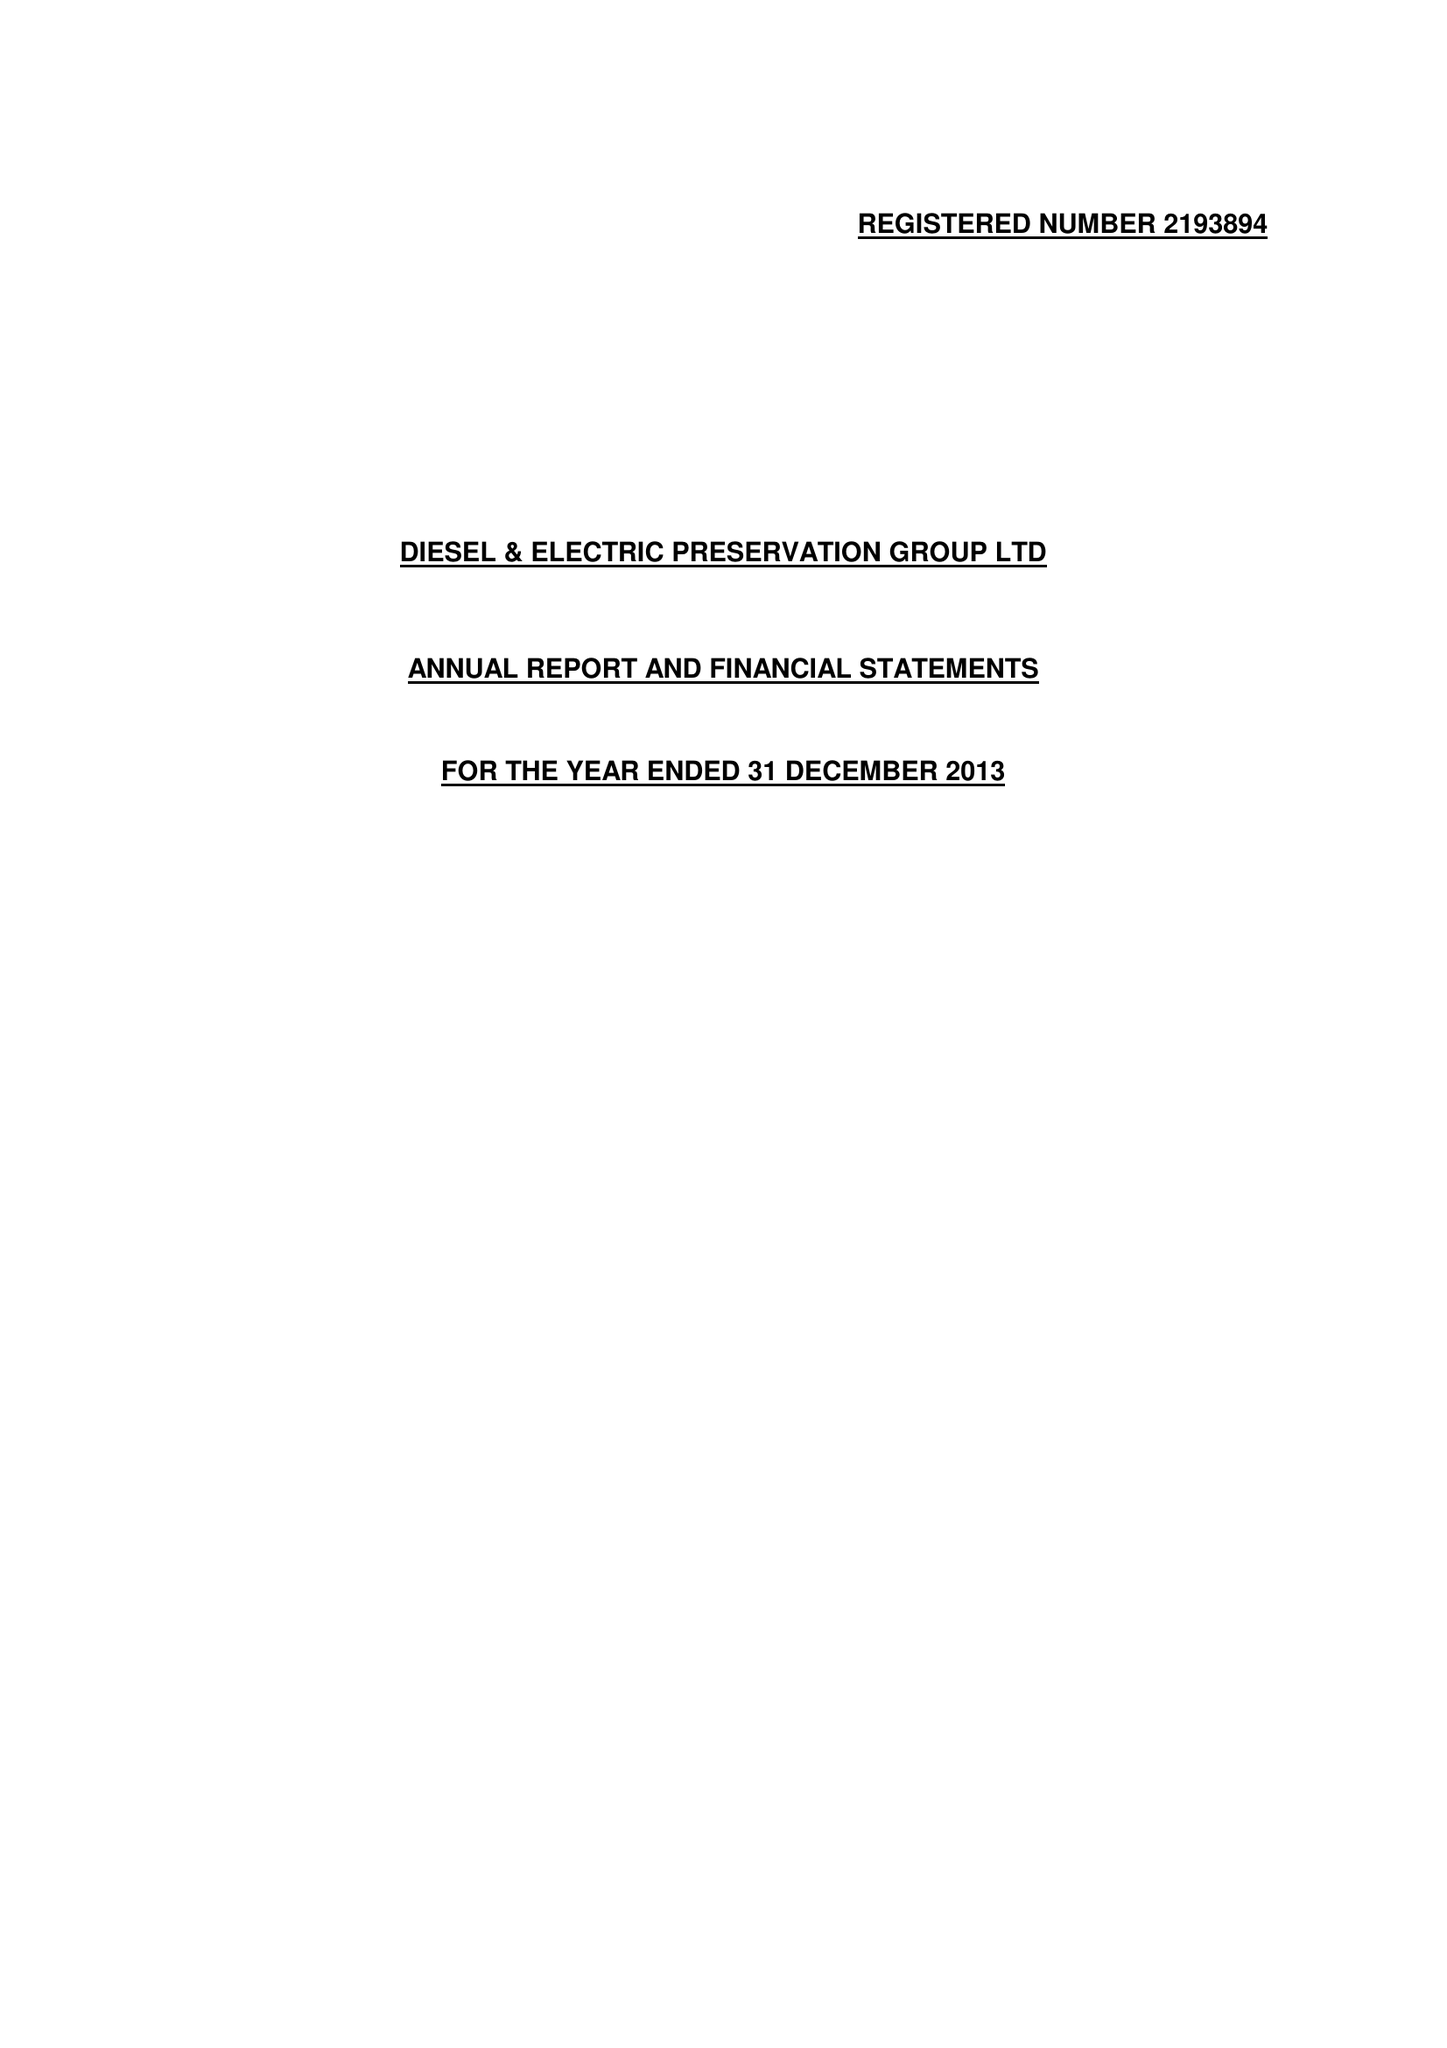What is the value for the charity_name?
Answer the question using a single word or phrase. The Diesel and Electric Preservation Group Ltd. 